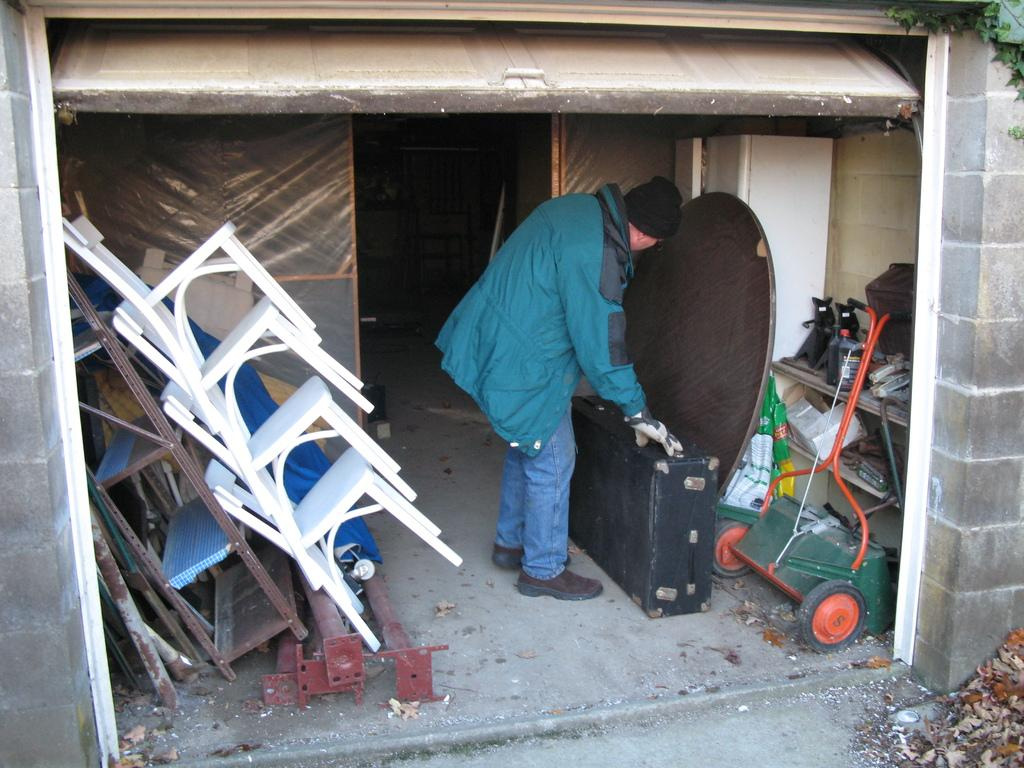What type of furniture can be seen in the image? There are chairs in the image. What is the man in the image doing? The man is standing and touching an object, which is a shelf. Can you describe the object the man is touching? The object is a shelf. What type of equipment is visible in the image? There is a grass cutting machine in the image. What type of advice can be seen written on the shelf in the image? There is no advice written on the shelf in the image; it is a physical object for storing items. What is the zinc content of the grass cutting machine in the image? There is no information about the zinc content of the grass cutting machine in the image. 